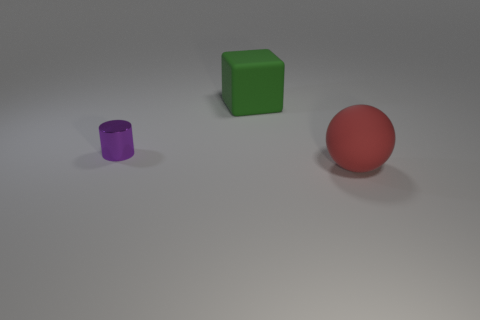Are there any other things that have the same material as the red sphere?
Provide a succinct answer. Yes. Is the number of red matte balls that are behind the small purple thing less than the number of green blocks to the left of the green block?
Give a very brief answer. No. Is there anything else that has the same color as the small cylinder?
Make the answer very short. No. What is the shape of the large green thing?
Give a very brief answer. Cube. There is a ball that is the same material as the green block; what is its color?
Keep it short and to the point. Red. Are there more large gray cylinders than tiny purple metal things?
Make the answer very short. No. Are there any tiny green matte blocks?
Keep it short and to the point. No. There is a matte object on the left side of the matte object right of the green cube; what is its shape?
Offer a terse response. Cube. What number of objects are matte cylinders or large things behind the purple object?
Give a very brief answer. 1. What color is the big rubber object in front of the small purple cylinder in front of the rubber object that is to the left of the large sphere?
Provide a succinct answer. Red. 